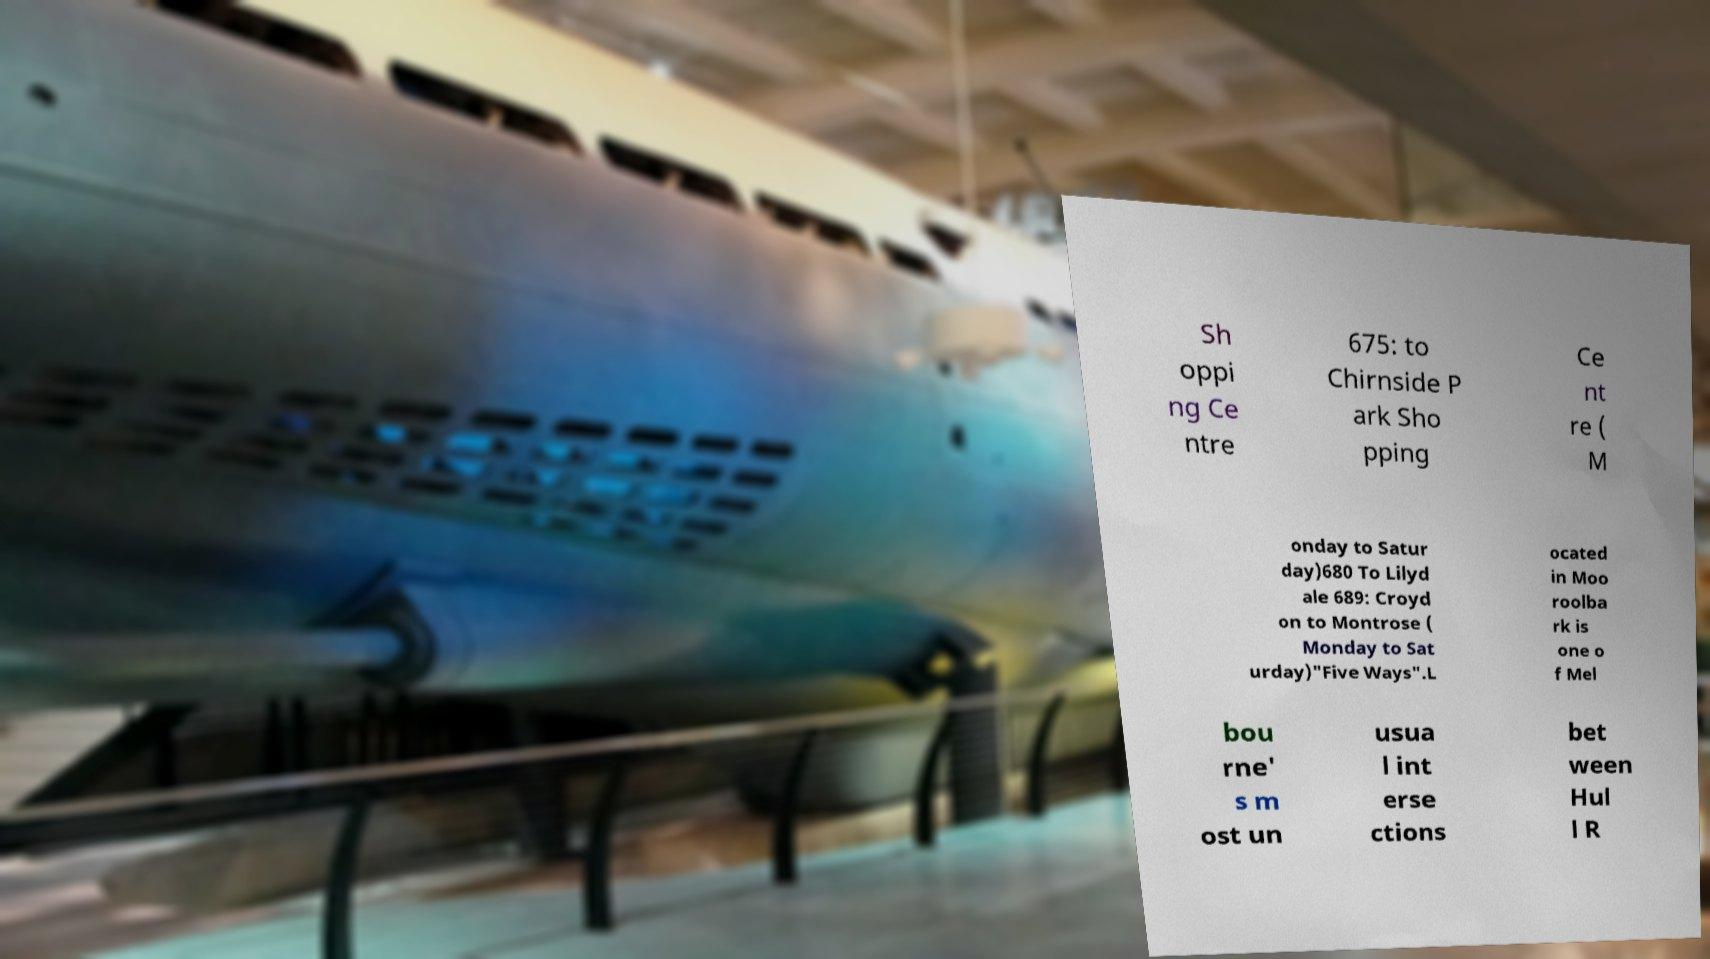Please identify and transcribe the text found in this image. Sh oppi ng Ce ntre 675: to Chirnside P ark Sho pping Ce nt re ( M onday to Satur day)680 To Lilyd ale 689: Croyd on to Montrose ( Monday to Sat urday)"Five Ways".L ocated in Moo roolba rk is one o f Mel bou rne' s m ost un usua l int erse ctions bet ween Hul l R 